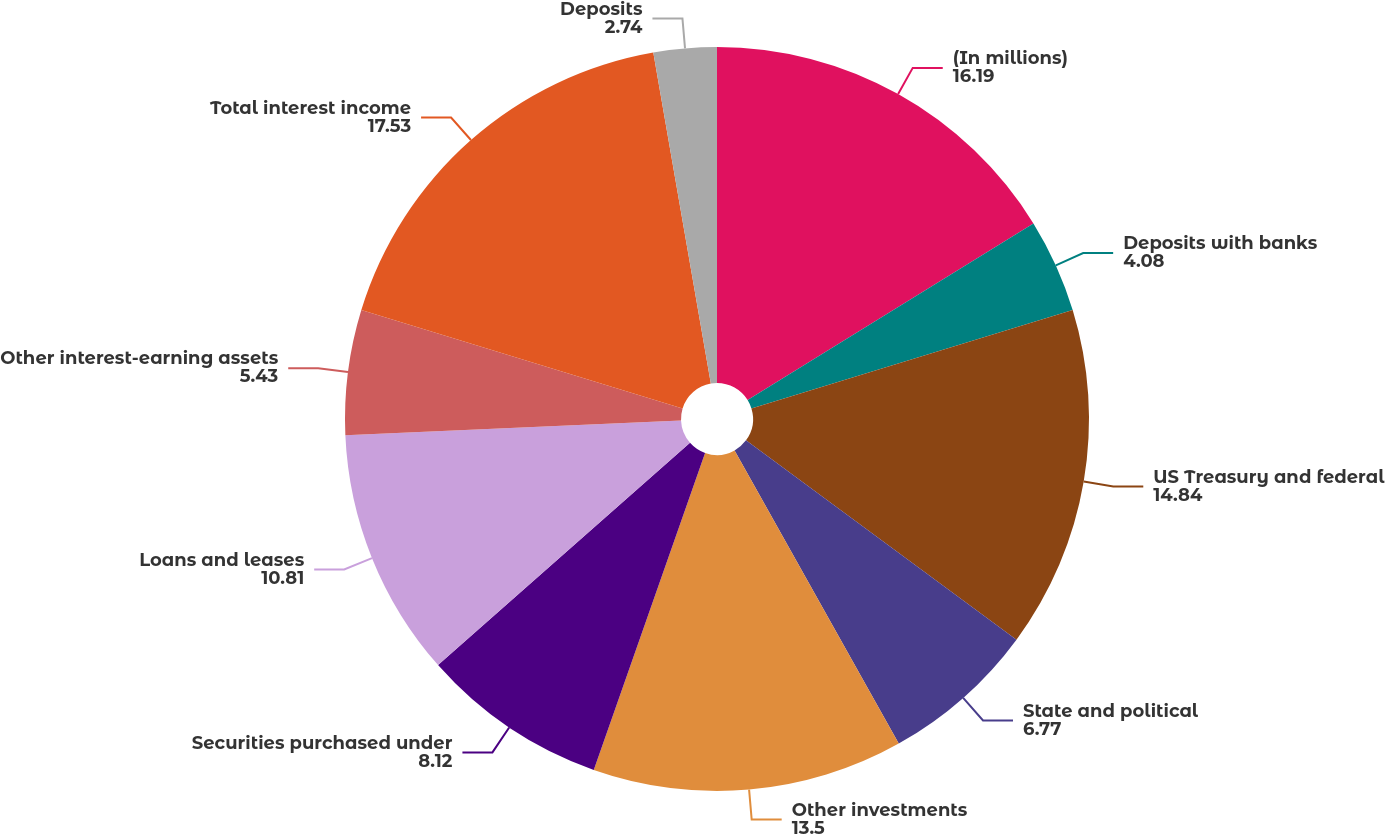Convert chart to OTSL. <chart><loc_0><loc_0><loc_500><loc_500><pie_chart><fcel>(In millions)<fcel>Deposits with banks<fcel>US Treasury and federal<fcel>State and political<fcel>Other investments<fcel>Securities purchased under<fcel>Loans and leases<fcel>Other interest-earning assets<fcel>Total interest income<fcel>Deposits<nl><fcel>16.19%<fcel>4.08%<fcel>14.84%<fcel>6.77%<fcel>13.5%<fcel>8.12%<fcel>10.81%<fcel>5.43%<fcel>17.53%<fcel>2.74%<nl></chart> 